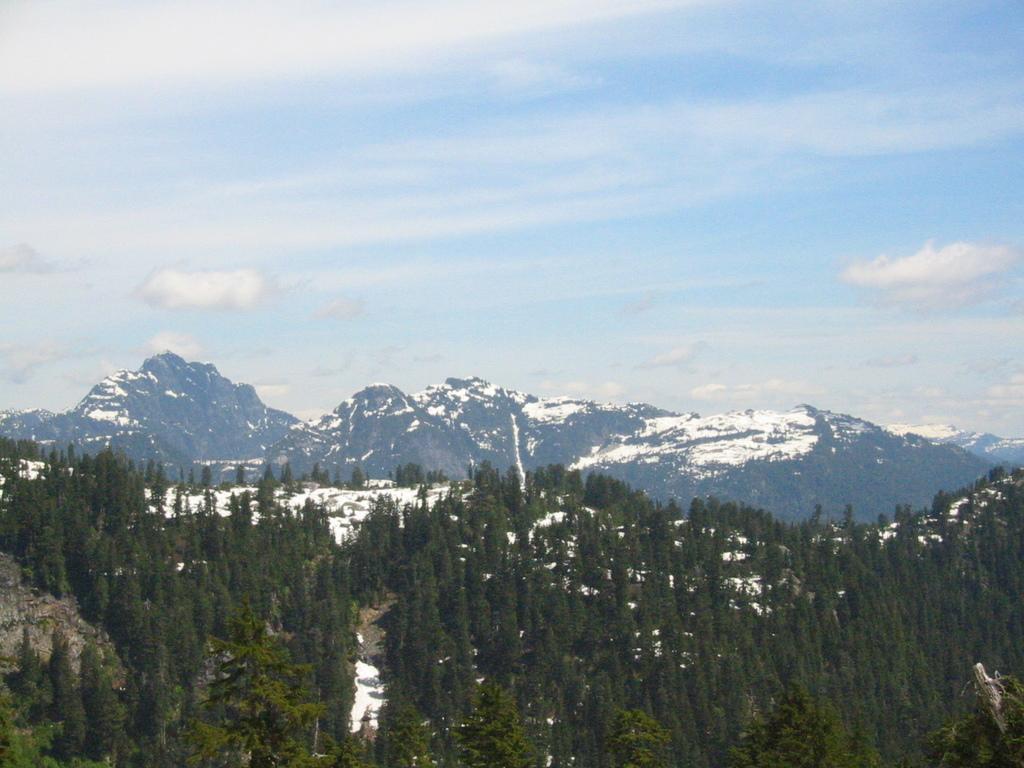Please provide a concise description of this image. This image consists of trees, snow, mountains and the sky. This image is taken may be near the mountains. 